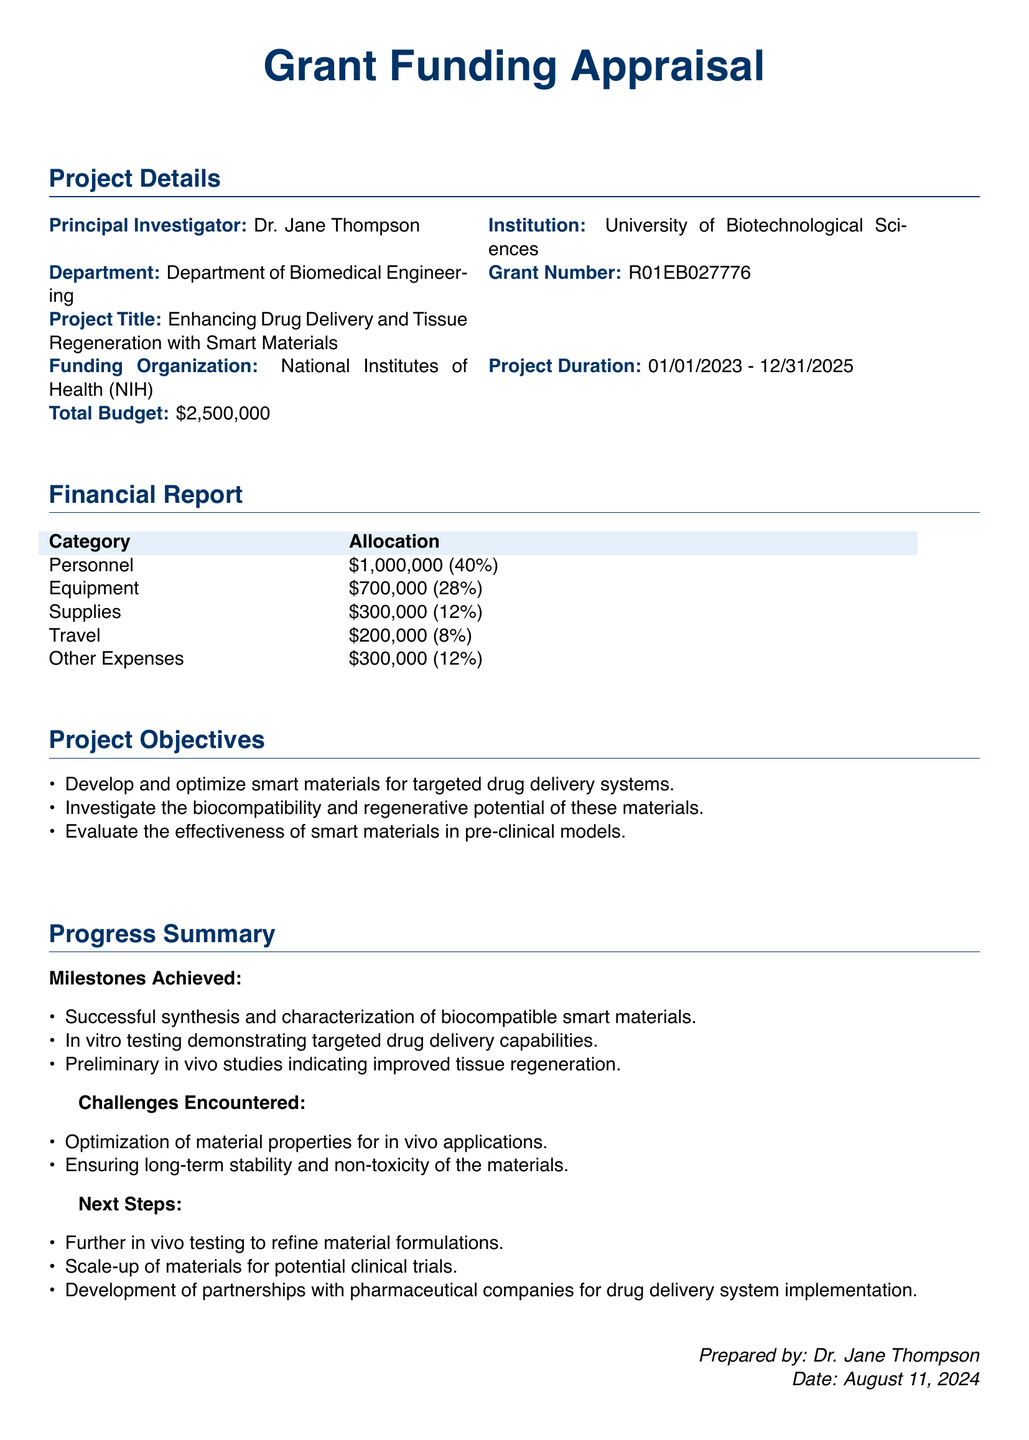What is the name of the Principal Investigator? The Principal Investigator is identified as Dr. Jane Thompson in the document.
Answer: Dr. Jane Thompson What is the total budget allocated for the project? The total budget for the project is specified in the financial report as $2,500,000.
Answer: $2,500,000 What organization is funding the grant? The funding organization is mentioned as the National Institutes of Health (NIH) in the project details.
Answer: National Institutes of Health (NIH) What percentage of the budget is allocated to personnel? The budget allocation for personnel is given as 40% in the financial report.
Answer: 40% What is the duration of the project? The project duration is outlined as starting on January 1, 2023, and ending on December 31, 2025.
Answer: 01/01/2023 - 12/31/2025 What is one of the challenges encountered in the project? The document lists challenges, one of which is the optimization of material properties for in vivo applications.
Answer: Optimization of material properties for in vivo applications What is a next step mentioned in the progress summary? The document states that a next step is to further in vivo testing to refine material formulations.
Answer: Further in vivo testing What type of testing has demonstrated targeted drug delivery capabilities? The progress summary mentions in vitro testing as the method demonstrating targeted drug delivery capabilities.
Answer: In vitro testing What is the total allocation for equipment? The financial report specifies that the total allocation for equipment is $700,000.
Answer: $700,000 